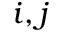<formula> <loc_0><loc_0><loc_500><loc_500>i , j</formula> 